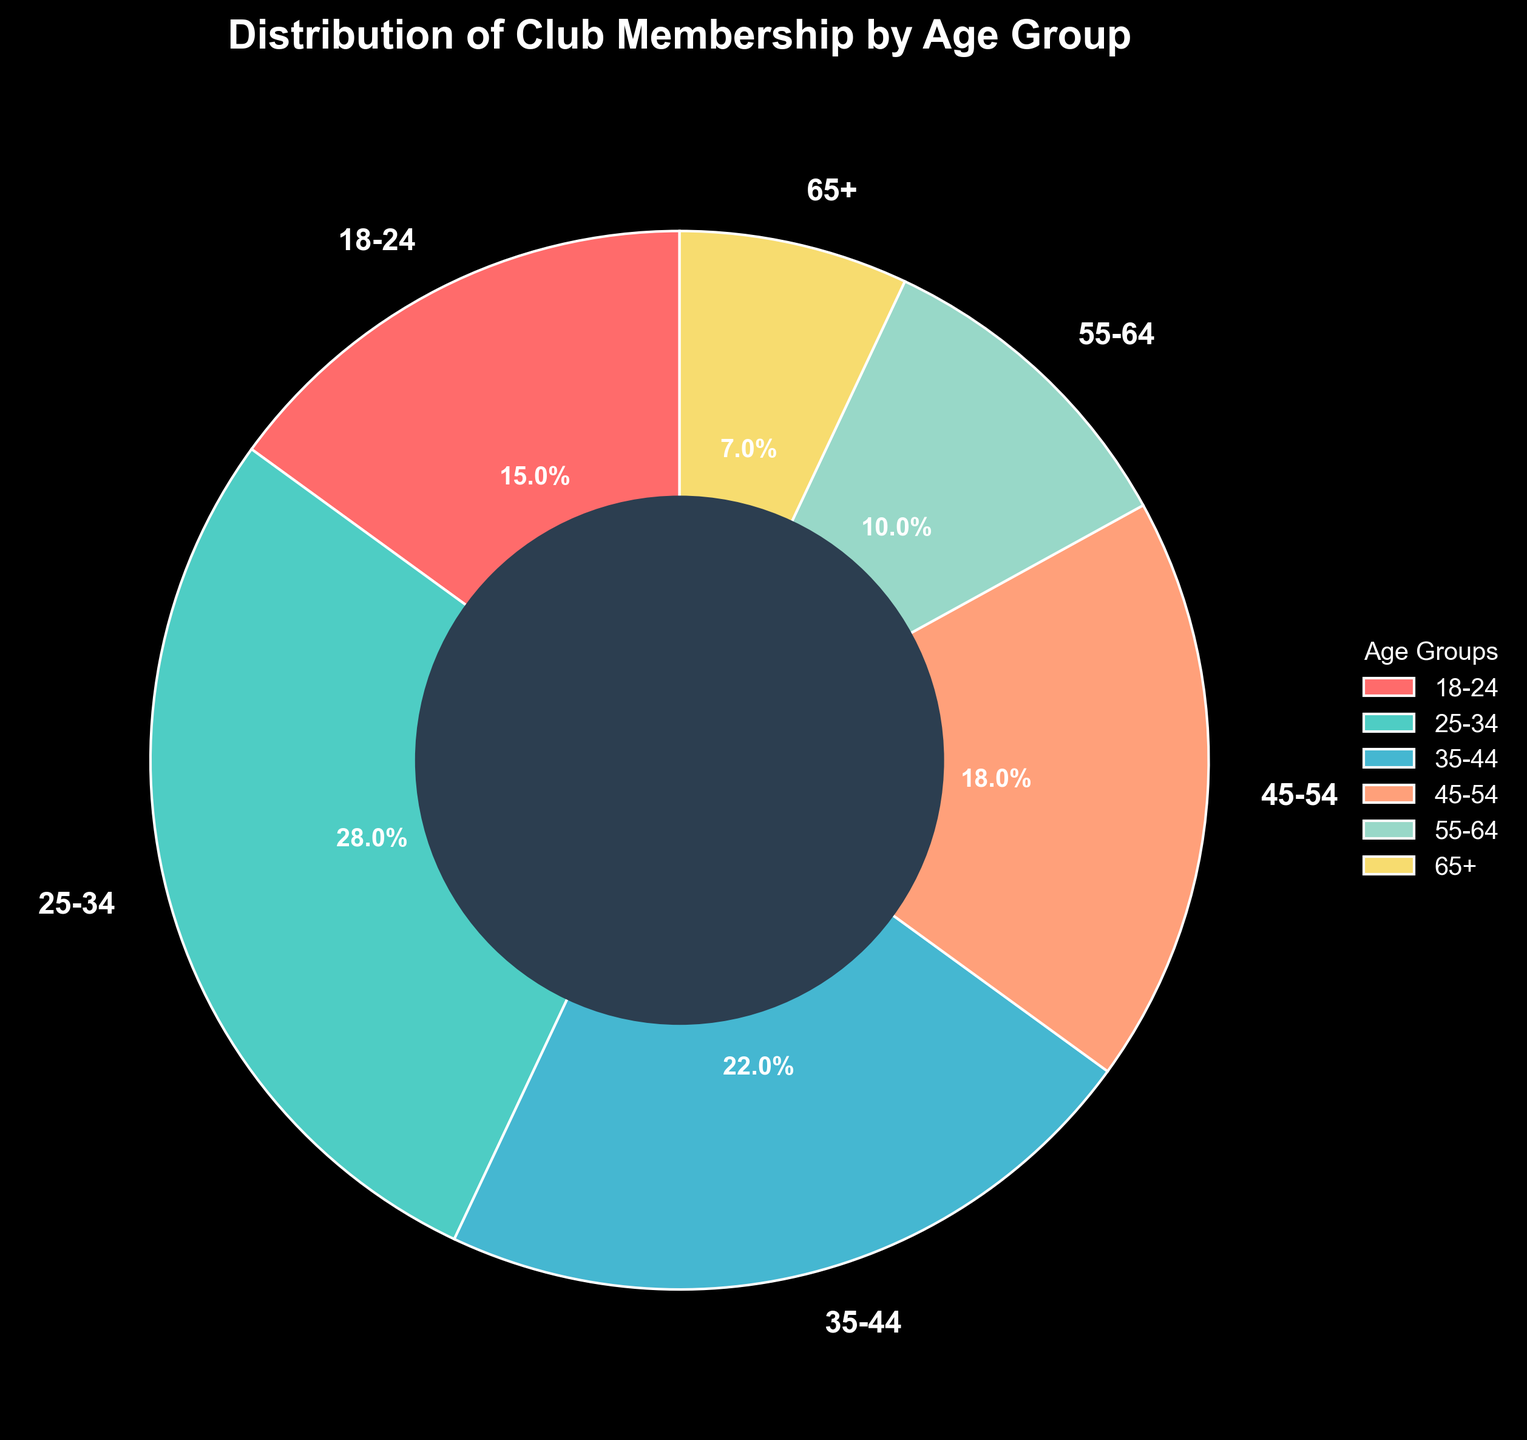Which age group has the highest percentage of club membership? By looking at the pie chart, we can see that the age group 25-34 holds the largest segment. This indicates that the highest percentage of club membership is in the 25-34 age group.
Answer: 25-34 What is the combined percentage of club members aged 45-54 and 55-64? To find the combined percentage, we add the percentages of the 45-54 and 55-64 age groups. The percentage for 45-54 is 18% and for 55-64 is 10%. Adding them together, we get 18% + 10% = 28%.
Answer: 28% How much larger is the membership percentage of the 25-34 age group compared to the 65+ age group? To determine the difference, we subtract the percentage of the 65+ age group from that of the 25-34 age group. The percentage for 25-34 is 28% and for 65+ is 7%. Therefore, 28% - 7% = 21%.
Answer: 21% What is the smallest age group in terms of membership percentage? By examining the pie chart, we can identify that the smallest segment belongs to the 65+ age group, which has the lowest percentage of club membership.
Answer: 65+ What is the average percentage for the age groups 18-24, 35-44, and 55-64? To find the average, we first sum the percentages of the 18-24, 35-44, and 55-64 age groups: 15% + 22% + 10% = 47%. Then, we divide by the number of groups: 47% / 3 = 15.67%.
Answer: 15.67% Which age groups have a combined percentage greater than that of the 25-34 age group? We need to find which sets of age groups have a total percentage greater than 28% (the percentage of the 25-34 group). The groups 18-24 (15%) and 35-44 (22%) together make 37%, which is greater than 28%. Similarly, the groups 45-54 (18%) and 55-64 (10%) together make 28%. The groups 35-44 (22%) and 45-54 (18%) sum up to 40%.
Answer: 18-24 and 35-44; 35-44 and 45-54 What color is used to represent the 35-44 age group? The pie chart uses specific colors to represent each age group, and by checking the legend, we can see that the color representing 35-44 is a shade of blue.
Answer: Blue How does the membership percentage of the 18-24 age group compare to that of the 55-64 age group? By comparing the sizes of the segments in the pie chart, we see that the percentage for the 18-24 age group is 15%, and for the 55-64 age group, it is 10%. Therefore, the 18-24 group has a higher membership percentage by 5%.
Answer: 15% > 10% 